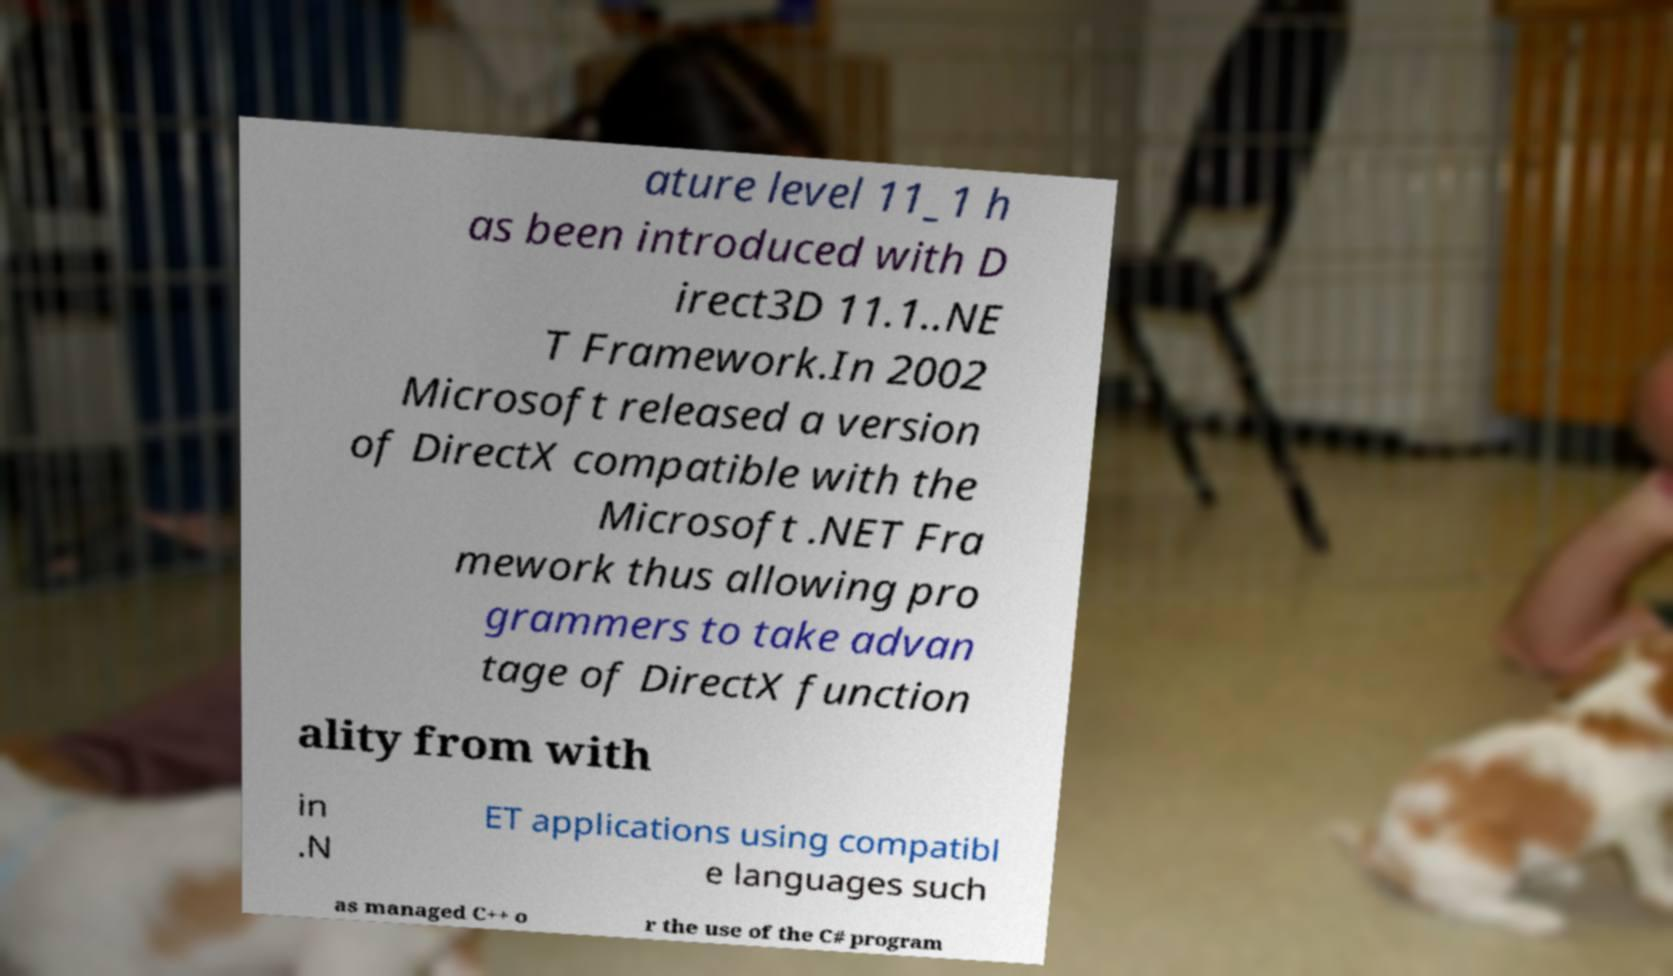Could you extract and type out the text from this image? ature level 11_1 h as been introduced with D irect3D 11.1..NE T Framework.In 2002 Microsoft released a version of DirectX compatible with the Microsoft .NET Fra mework thus allowing pro grammers to take advan tage of DirectX function ality from with in .N ET applications using compatibl e languages such as managed C++ o r the use of the C# program 